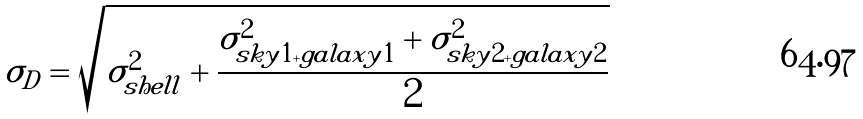<formula> <loc_0><loc_0><loc_500><loc_500>\sigma _ { D } = \sqrt { \sigma _ { s h e l l } ^ { 2 } + \frac { \sigma _ { s k y 1 + g a l a x y 1 } ^ { 2 } + \sigma _ { s k y 2 + g a l a x y 2 } ^ { 2 } } { 2 } }</formula> 